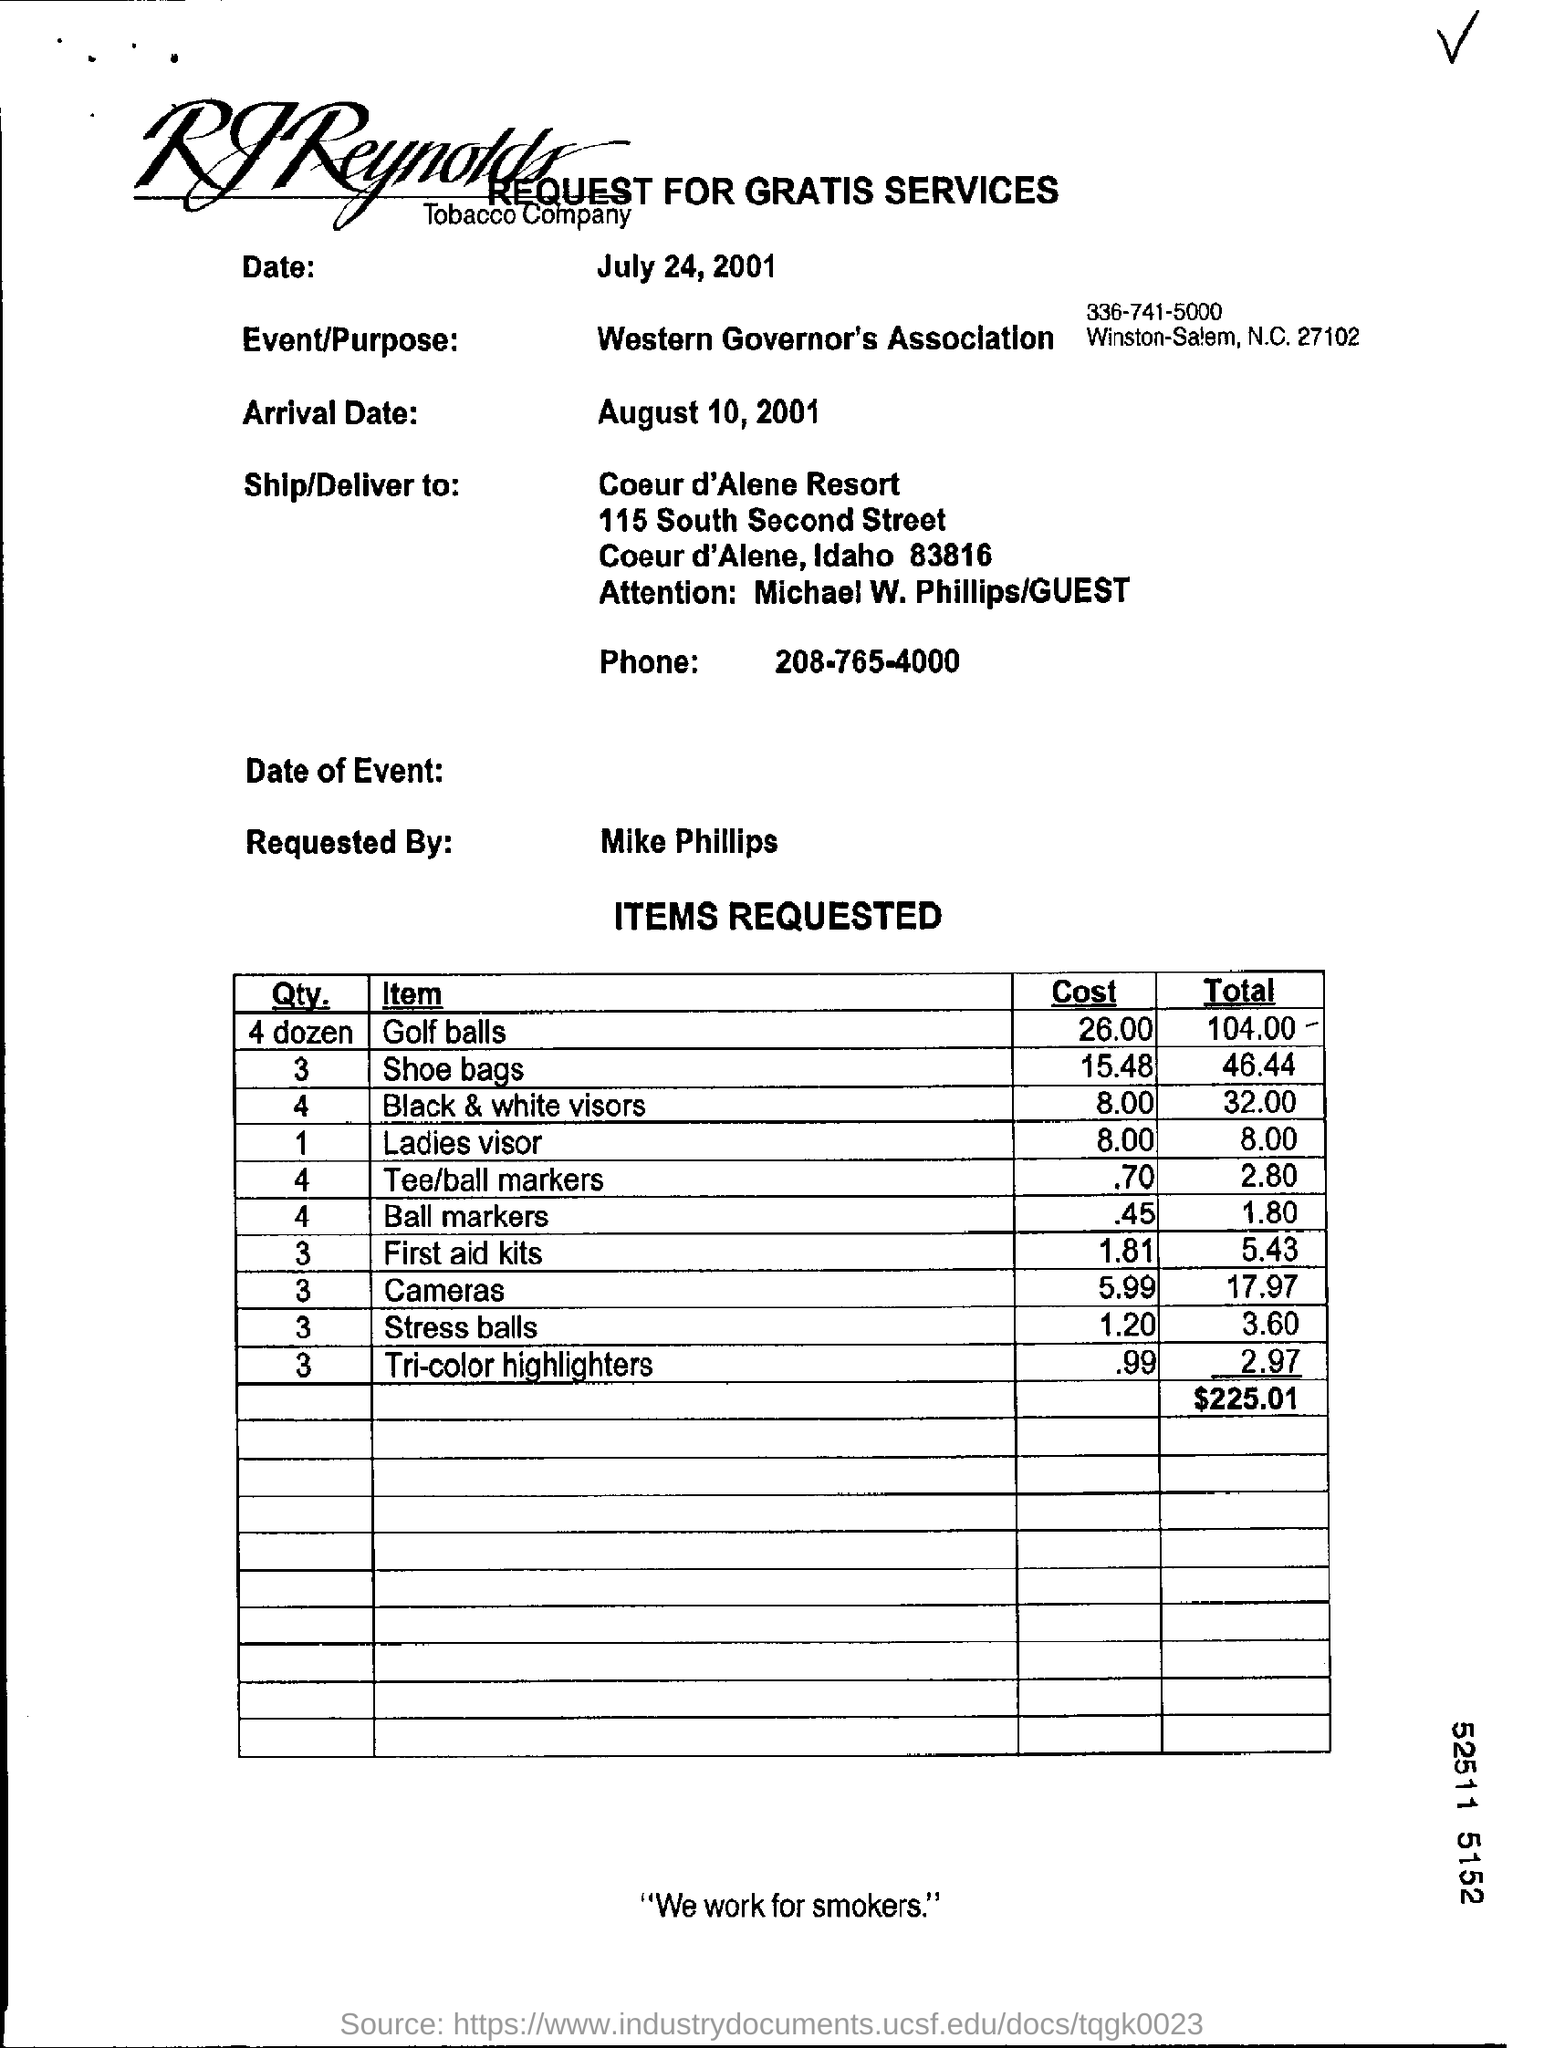What kind of request form is this?
Make the answer very short. REQUEST FOR GRATIS SERVICES. What is event/purpose ?
Give a very brief answer. Western Governor's Association. What is the arrival date?
Keep it short and to the point. August 10,2001. What is the phone number in the documber?
Give a very brief answer. 208-765-4000. 